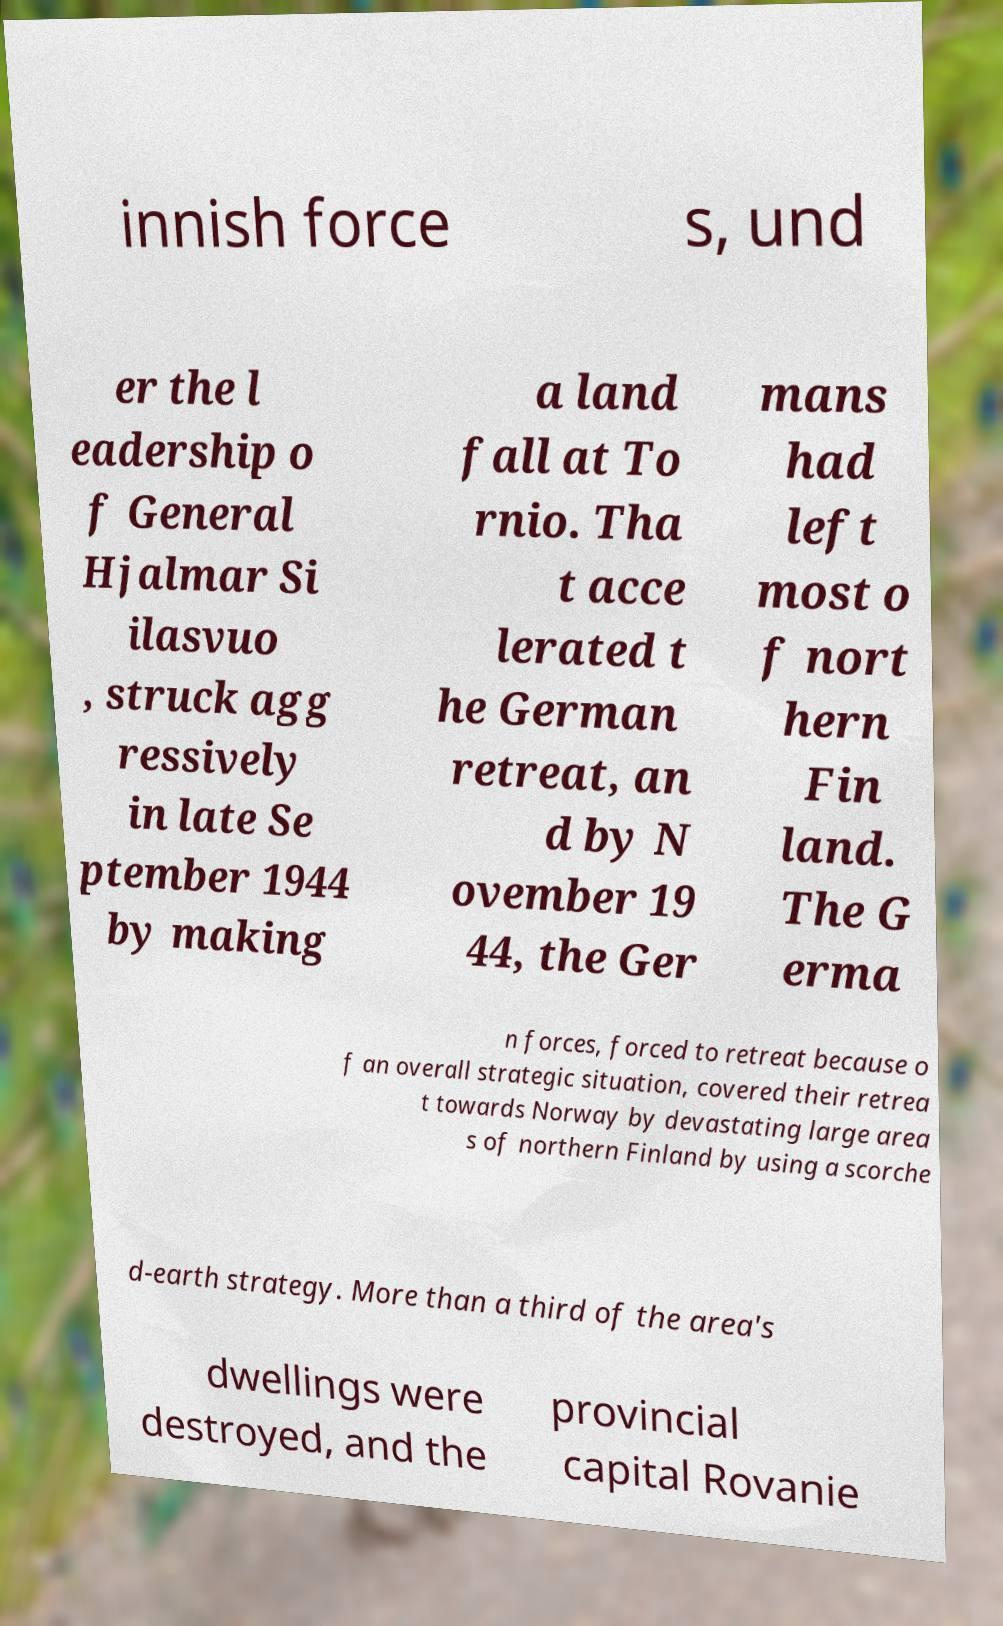Please identify and transcribe the text found in this image. innish force s, und er the l eadership o f General Hjalmar Si ilasvuo , struck agg ressively in late Se ptember 1944 by making a land fall at To rnio. Tha t acce lerated t he German retreat, an d by N ovember 19 44, the Ger mans had left most o f nort hern Fin land. The G erma n forces, forced to retreat because o f an overall strategic situation, covered their retrea t towards Norway by devastating large area s of northern Finland by using a scorche d-earth strategy. More than a third of the area's dwellings were destroyed, and the provincial capital Rovanie 